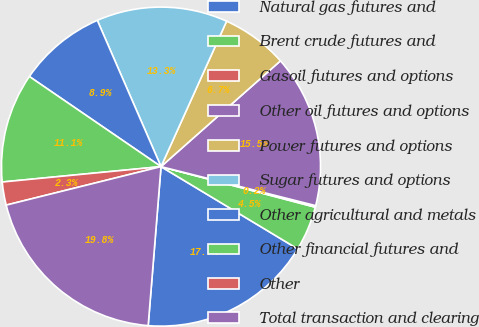Convert chart. <chart><loc_0><loc_0><loc_500><loc_500><pie_chart><fcel>Natural gas futures and<fcel>Brent crude futures and<fcel>Gasoil futures and options<fcel>Other oil futures and options<fcel>Power futures and options<fcel>Sugar futures and options<fcel>Other agricultural and metals<fcel>Other financial futures and<fcel>Other<fcel>Total transaction and clearing<nl><fcel>17.66%<fcel>4.53%<fcel>0.16%<fcel>15.47%<fcel>6.72%<fcel>13.28%<fcel>8.91%<fcel>11.09%<fcel>2.34%<fcel>19.84%<nl></chart> 